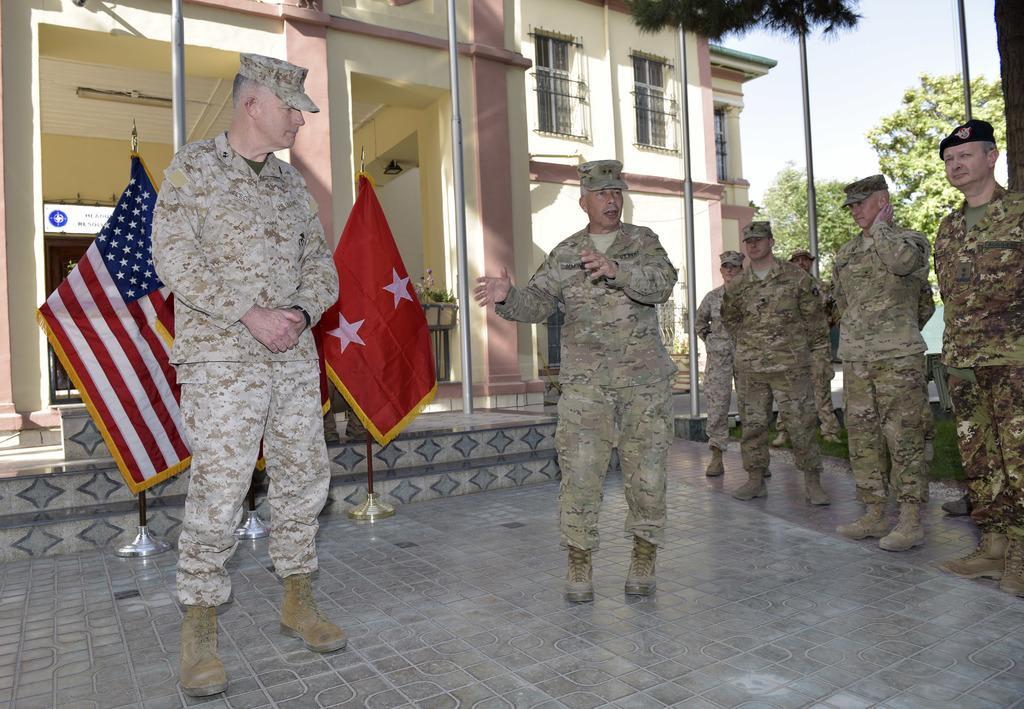In one or two sentences, can you explain what this image depicts? This image consists of many persons wearing army dresses. At the bottom, there is a floor. In the background, there are flags along with a building. To the right, there are trees. 